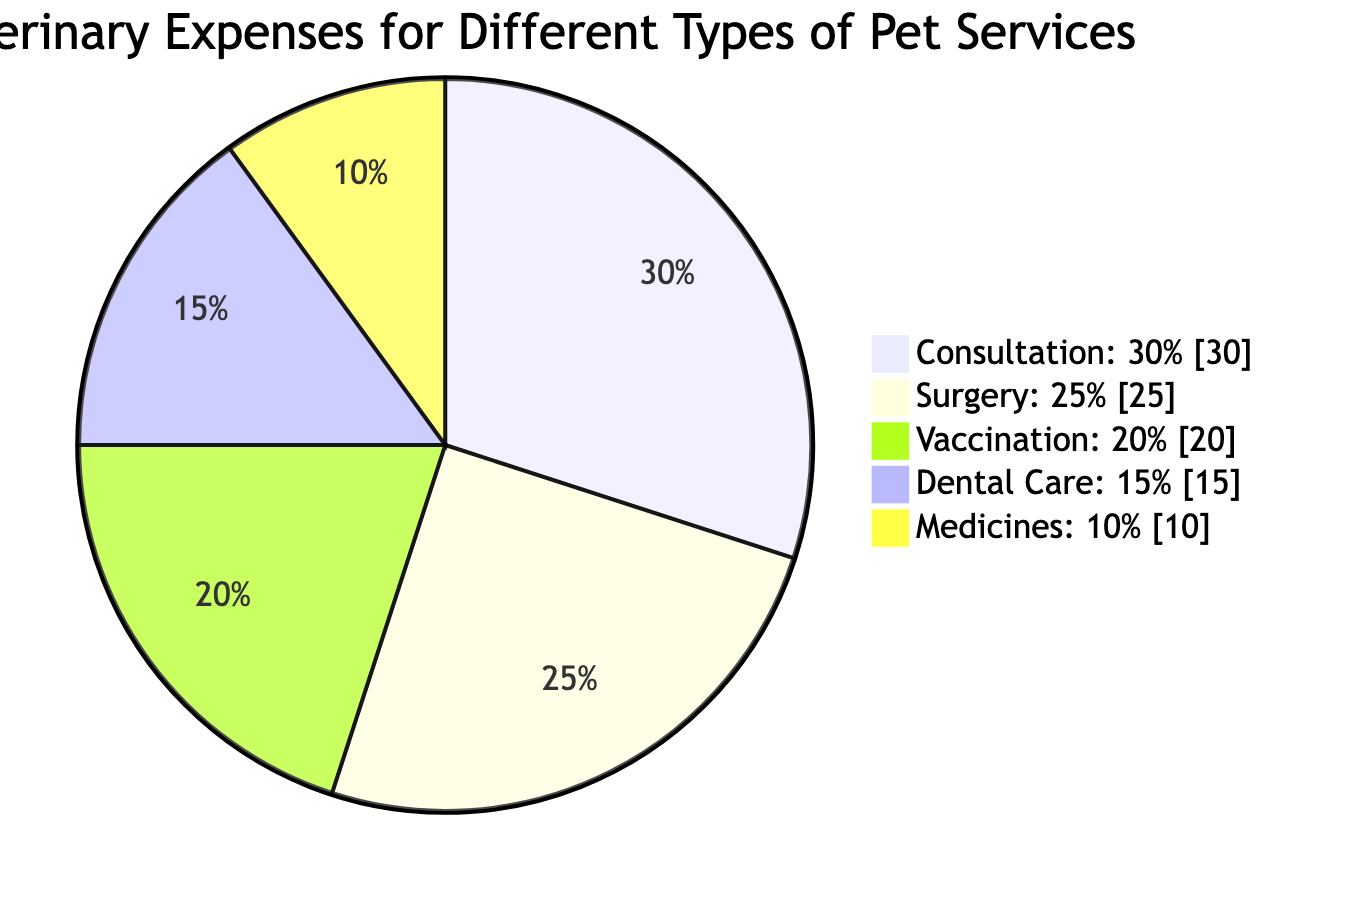What is the percentage distribution for Consultation services? The diagram shows that Consultation services account for 30% of the annual veterinary expenses, as indicated by the label next to that segment of the pie chart.
Answer: 30% Which service has the lowest percentage in annual veterinary expenses? In the pie chart, Medicines are represented with the smallest segment at 10%, which shows they have the lowest percentage of the expenses compared to other services.
Answer: Medicines What is the combined percentage of Surgery and Dental Care? To find the combined percentage, add the percentages of Surgery (25%) and Dental Care (15%). This yields a total of 40% for those two services combined.
Answer: 40% Which pet service accounts for 20% of the expenses? The diagram explicitly states that Vaccination services account for 20% of the total annual veterinary expenses, identifiable by the segment labeled Vaccination.
Answer: Vaccination What is the ratio of Dental Care expenses to Surgery expenses? The percentages for Dental Care (15%) and Surgery (25%) can be compared. To find the ratio, calculate 15:25, which reduces to 3:5 after simplifying.
Answer: 3:5 What percentage of expenses is accounted for by Consultation and Vaccination combined? Consultation accounts for 30% and Vaccination for 20%, so adding these together gives a combined total of 50%.
Answer: 50% How many types of services are represented in the diagram? The diagram includes five different services represented with their respective percentages, which can be counted directly from the diagram.
Answer: 5 